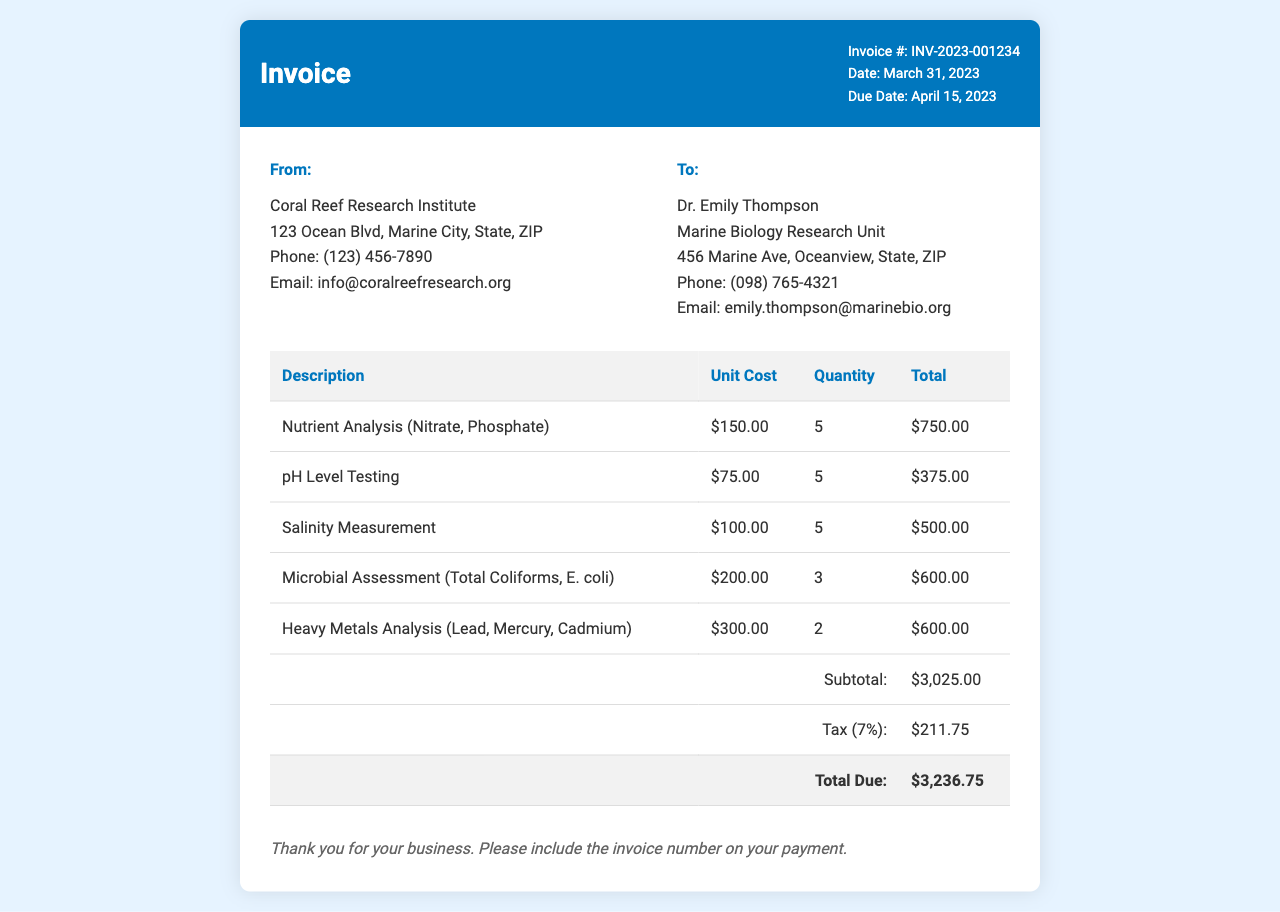What is the invoice number? The invoice number is found in the document header, indicating a unique identification for the invoice.
Answer: INV-2023-001234 Who is the service provider? The service provider's name appears in the top section of the invoice, indicating the organization issuing the invoice.
Answer: Coral Reef Research Institute What was the date of the invoice? The date of the invoice is displayed prominently, showing when the invoice was issued.
Answer: March 31, 2023 How many Nutrient Analysis tests were performed? The quantity of Nutrient Analysis tests is specified in the table under the description of the test.
Answer: 5 What is the subtotal amount? The subtotal is calculated before tax and can be found at the end of the itemized list of services.
Answer: $3,025.00 What is the tax rate applied? The tax rate is noted in the table, giving information on the percentage of tax charged on the subtotal.
Answer: 7% What is the total amount due? The total amount due is calculated after adding the subtotal and tax, reflected as the final amount in the invoice.
Answer: $3,236.75 Who is the invoice recipient? The recipient's name appears in the section labeled "To," indicating to whom the invoice is addressed.
Answer: Dr. Emily Thompson What types of tests were included in the analysis? The types of tests are listed in the itemized section, providing an overview of the laboratory services rendered.
Answer: Nutrient Analysis, pH Level Testing, Salinity Measurement, Microbial Assessment, Heavy Metals Analysis 